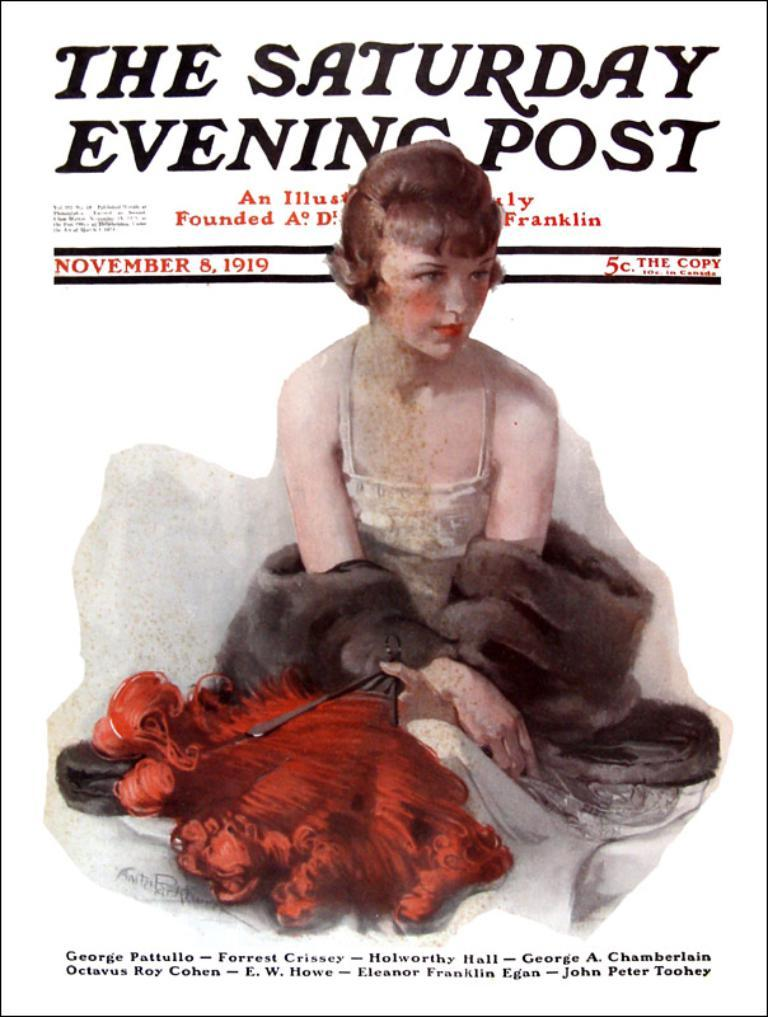What type of visual is the image? The image is a poster. What is the woman in the image doing? The woman is sitting in the image. What is the woman holding in the image? The woman is holding an object. Can you describe the text on the poster? There is text at the top and bottom of the image. What is the color of the background in the image? The background of the poster is white. Can you tell me how many boats are docked at the harbor in the image? There is no harbor or boats present in the image; it is a poster featuring a woman sitting and holding an object. What type of cart is being used to transport the route in the image? There is no cart or route present in the image; it is a poster with a woman sitting and holding an object against a white background. 